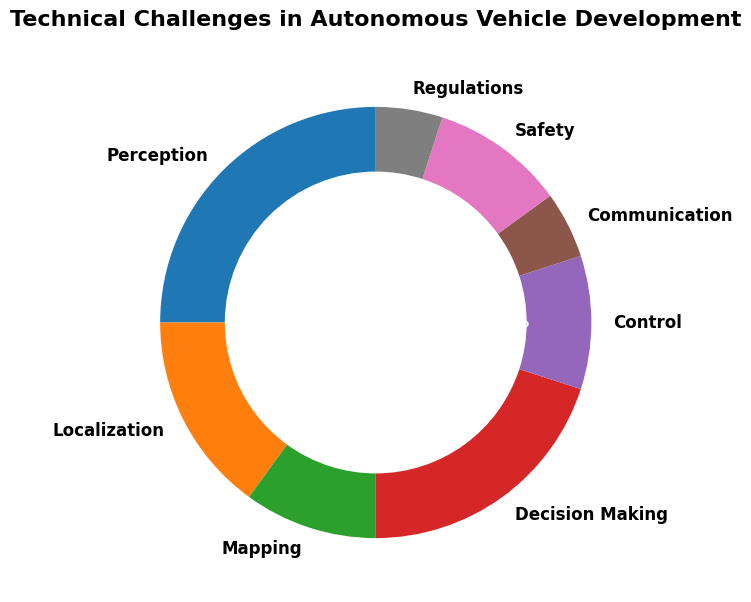Which category is the most prevalent in the technical challenges of autonomous vehicle development? The largest wedge in the chart represents the most prevalent category. In this case, 'Perception' has the highest percentage.
Answer: Perception Which category has the least prevalence in the technical challenges? The smallest wedge in the chart represents the least prevalent category. 'Communication' and 'Regulations' both share the smallest percentages.
Answer: Communication and Regulations What is the combined prevalence of Decision Making and Control? Add the prevalence values for 'Decision Making' (20) and 'Control' (10). 20 + 10 = 30.
Answer: 30% Is Perception more prevalent than the combination of Mapping and Safety? 'Perception' has 25%. 'Mapping' and 'Safety' have 10% each, summing to 20%. Compare 25% and 20%, and 25% is larger.
Answer: Yes What percentage of the challenges are related to Perception, Localization, and Mapping combined? Add the prevalence values for 'Perception' (25), 'Localization' (15), and 'Mapping' (10). 25 + 15 + 10 = 50.
Answer: 50% Which categories share the same level of prevalence? The categories with the same size wedge represent the same prevalence. 'Mapping', 'Control', and 'Safety' all have 10%, while 'Communication' and 'Regulations' both have 5%.
Answer: Mapping, Control, and Safety; Communication and Regulations How much more prevalent is Decision Making compared to Communication? Subtract the prevalence values of 'Communication' (5) from 'Decision Making' (20). 20 - 5 = 15.
Answer: 15% Is the prevalence of Safety equal to the prevalence of Control? Both 'Safety' and 'Control' have the same wedge sizes in the chart, each with a 10% prevalence.
Answer: Yes What's the average prevalence of Localization and Mapping? Add the prevalence values for 'Localization' (15) and 'Mapping' (10), then divide by two. (15 + 10) / 2 = 12.5.
Answer: 12.5% What proportion of the total does the decision-making category contribute? 'Decision Making' comprises 20% of the challenges.
Answer: 20% 